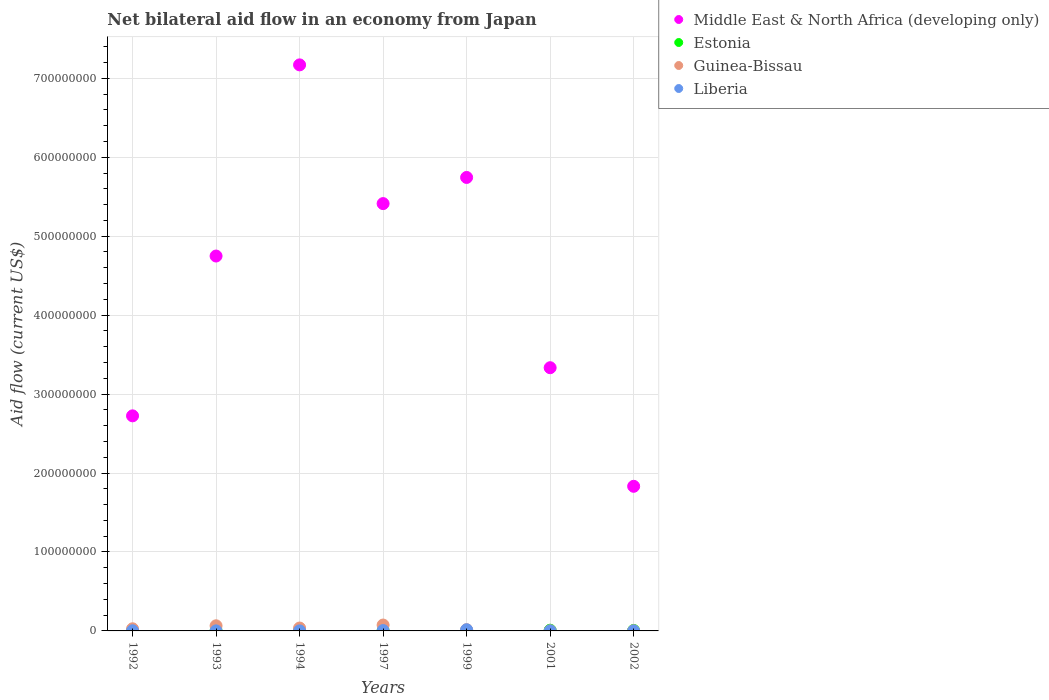Is the number of dotlines equal to the number of legend labels?
Make the answer very short. Yes. What is the net bilateral aid flow in Middle East & North Africa (developing only) in 1993?
Ensure brevity in your answer.  4.75e+08. Across all years, what is the minimum net bilateral aid flow in Estonia?
Keep it short and to the point. 3.00e+04. What is the total net bilateral aid flow in Liberia in the graph?
Provide a short and direct response. 2.28e+06. What is the difference between the net bilateral aid flow in Estonia in 1997 and that in 2001?
Keep it short and to the point. -6.80e+05. What is the difference between the net bilateral aid flow in Guinea-Bissau in 1992 and the net bilateral aid flow in Estonia in 1999?
Keep it short and to the point. 2.40e+06. What is the average net bilateral aid flow in Liberia per year?
Offer a terse response. 3.26e+05. In the year 1997, what is the difference between the net bilateral aid flow in Guinea-Bissau and net bilateral aid flow in Liberia?
Give a very brief answer. 7.01e+06. What is the ratio of the net bilateral aid flow in Estonia in 1997 to that in 1999?
Your answer should be compact. 0.73. What is the difference between the highest and the second highest net bilateral aid flow in Liberia?
Offer a very short reply. 1.02e+06. What is the difference between the highest and the lowest net bilateral aid flow in Middle East & North Africa (developing only)?
Make the answer very short. 5.34e+08. Is the sum of the net bilateral aid flow in Middle East & North Africa (developing only) in 1999 and 2001 greater than the maximum net bilateral aid flow in Liberia across all years?
Provide a short and direct response. Yes. Does the net bilateral aid flow in Estonia monotonically increase over the years?
Your answer should be very brief. No. Is the net bilateral aid flow in Guinea-Bissau strictly greater than the net bilateral aid flow in Estonia over the years?
Offer a very short reply. No. How many years are there in the graph?
Keep it short and to the point. 7. Does the graph contain any zero values?
Keep it short and to the point. No. How many legend labels are there?
Provide a short and direct response. 4. What is the title of the graph?
Ensure brevity in your answer.  Net bilateral aid flow in an economy from Japan. What is the label or title of the X-axis?
Ensure brevity in your answer.  Years. What is the Aid flow (current US$) in Middle East & North Africa (developing only) in 1992?
Keep it short and to the point. 2.72e+08. What is the Aid flow (current US$) of Estonia in 1992?
Ensure brevity in your answer.  3.00e+04. What is the Aid flow (current US$) of Guinea-Bissau in 1992?
Your answer should be very brief. 2.70e+06. What is the Aid flow (current US$) in Liberia in 1992?
Your answer should be compact. 2.00e+05. What is the Aid flow (current US$) in Middle East & North Africa (developing only) in 1993?
Your answer should be very brief. 4.75e+08. What is the Aid flow (current US$) of Estonia in 1993?
Your response must be concise. 1.30e+05. What is the Aid flow (current US$) of Guinea-Bissau in 1993?
Ensure brevity in your answer.  6.51e+06. What is the Aid flow (current US$) in Liberia in 1993?
Give a very brief answer. 6.00e+04. What is the Aid flow (current US$) of Middle East & North Africa (developing only) in 1994?
Provide a succinct answer. 7.17e+08. What is the Aid flow (current US$) in Guinea-Bissau in 1994?
Make the answer very short. 3.66e+06. What is the Aid flow (current US$) in Middle East & North Africa (developing only) in 1997?
Make the answer very short. 5.41e+08. What is the Aid flow (current US$) of Guinea-Bissau in 1997?
Make the answer very short. 7.46e+06. What is the Aid flow (current US$) of Middle East & North Africa (developing only) in 1999?
Offer a very short reply. 5.74e+08. What is the Aid flow (current US$) of Estonia in 1999?
Offer a very short reply. 3.00e+05. What is the Aid flow (current US$) in Guinea-Bissau in 1999?
Ensure brevity in your answer.  1.53e+06. What is the Aid flow (current US$) in Liberia in 1999?
Your response must be concise. 1.47e+06. What is the Aid flow (current US$) in Middle East & North Africa (developing only) in 2001?
Make the answer very short. 3.33e+08. What is the Aid flow (current US$) of Guinea-Bissau in 2001?
Keep it short and to the point. 1.80e+05. What is the Aid flow (current US$) in Middle East & North Africa (developing only) in 2002?
Make the answer very short. 1.83e+08. What is the Aid flow (current US$) in Estonia in 2002?
Offer a very short reply. 6.10e+05. Across all years, what is the maximum Aid flow (current US$) of Middle East & North Africa (developing only)?
Your answer should be very brief. 7.17e+08. Across all years, what is the maximum Aid flow (current US$) of Estonia?
Your response must be concise. 9.00e+05. Across all years, what is the maximum Aid flow (current US$) in Guinea-Bissau?
Ensure brevity in your answer.  7.46e+06. Across all years, what is the maximum Aid flow (current US$) of Liberia?
Make the answer very short. 1.47e+06. Across all years, what is the minimum Aid flow (current US$) of Middle East & North Africa (developing only)?
Keep it short and to the point. 1.83e+08. Across all years, what is the minimum Aid flow (current US$) of Guinea-Bissau?
Ensure brevity in your answer.  1.20e+05. Across all years, what is the minimum Aid flow (current US$) in Liberia?
Give a very brief answer. 2.00e+04. What is the total Aid flow (current US$) in Middle East & North Africa (developing only) in the graph?
Offer a terse response. 3.10e+09. What is the total Aid flow (current US$) of Estonia in the graph?
Your response must be concise. 2.27e+06. What is the total Aid flow (current US$) of Guinea-Bissau in the graph?
Your response must be concise. 2.22e+07. What is the total Aid flow (current US$) in Liberia in the graph?
Make the answer very short. 2.28e+06. What is the difference between the Aid flow (current US$) of Middle East & North Africa (developing only) in 1992 and that in 1993?
Provide a succinct answer. -2.02e+08. What is the difference between the Aid flow (current US$) of Guinea-Bissau in 1992 and that in 1993?
Offer a terse response. -3.81e+06. What is the difference between the Aid flow (current US$) of Liberia in 1992 and that in 1993?
Offer a very short reply. 1.40e+05. What is the difference between the Aid flow (current US$) in Middle East & North Africa (developing only) in 1992 and that in 1994?
Ensure brevity in your answer.  -4.45e+08. What is the difference between the Aid flow (current US$) in Guinea-Bissau in 1992 and that in 1994?
Your answer should be compact. -9.60e+05. What is the difference between the Aid flow (current US$) in Liberia in 1992 and that in 1994?
Your answer should be compact. 1.70e+05. What is the difference between the Aid flow (current US$) of Middle East & North Africa (developing only) in 1992 and that in 1997?
Provide a succinct answer. -2.69e+08. What is the difference between the Aid flow (current US$) of Estonia in 1992 and that in 1997?
Your answer should be compact. -1.90e+05. What is the difference between the Aid flow (current US$) in Guinea-Bissau in 1992 and that in 1997?
Your response must be concise. -4.76e+06. What is the difference between the Aid flow (current US$) in Liberia in 1992 and that in 1997?
Your response must be concise. -2.50e+05. What is the difference between the Aid flow (current US$) of Middle East & North Africa (developing only) in 1992 and that in 1999?
Make the answer very short. -3.02e+08. What is the difference between the Aid flow (current US$) in Guinea-Bissau in 1992 and that in 1999?
Give a very brief answer. 1.17e+06. What is the difference between the Aid flow (current US$) of Liberia in 1992 and that in 1999?
Ensure brevity in your answer.  -1.27e+06. What is the difference between the Aid flow (current US$) of Middle East & North Africa (developing only) in 1992 and that in 2001?
Your answer should be compact. -6.10e+07. What is the difference between the Aid flow (current US$) in Estonia in 1992 and that in 2001?
Provide a succinct answer. -8.70e+05. What is the difference between the Aid flow (current US$) of Guinea-Bissau in 1992 and that in 2001?
Provide a short and direct response. 2.52e+06. What is the difference between the Aid flow (current US$) of Liberia in 1992 and that in 2001?
Make the answer very short. 1.50e+05. What is the difference between the Aid flow (current US$) in Middle East & North Africa (developing only) in 1992 and that in 2002?
Ensure brevity in your answer.  8.92e+07. What is the difference between the Aid flow (current US$) in Estonia in 1992 and that in 2002?
Make the answer very short. -5.80e+05. What is the difference between the Aid flow (current US$) in Guinea-Bissau in 1992 and that in 2002?
Keep it short and to the point. 2.58e+06. What is the difference between the Aid flow (current US$) of Liberia in 1992 and that in 2002?
Your answer should be very brief. 1.80e+05. What is the difference between the Aid flow (current US$) in Middle East & North Africa (developing only) in 1993 and that in 1994?
Provide a succinct answer. -2.42e+08. What is the difference between the Aid flow (current US$) in Estonia in 1993 and that in 1994?
Give a very brief answer. 5.00e+04. What is the difference between the Aid flow (current US$) of Guinea-Bissau in 1993 and that in 1994?
Provide a short and direct response. 2.85e+06. What is the difference between the Aid flow (current US$) of Liberia in 1993 and that in 1994?
Provide a short and direct response. 3.00e+04. What is the difference between the Aid flow (current US$) of Middle East & North Africa (developing only) in 1993 and that in 1997?
Your response must be concise. -6.64e+07. What is the difference between the Aid flow (current US$) of Estonia in 1993 and that in 1997?
Keep it short and to the point. -9.00e+04. What is the difference between the Aid flow (current US$) of Guinea-Bissau in 1993 and that in 1997?
Provide a short and direct response. -9.50e+05. What is the difference between the Aid flow (current US$) in Liberia in 1993 and that in 1997?
Provide a succinct answer. -3.90e+05. What is the difference between the Aid flow (current US$) of Middle East & North Africa (developing only) in 1993 and that in 1999?
Offer a very short reply. -9.96e+07. What is the difference between the Aid flow (current US$) in Estonia in 1993 and that in 1999?
Offer a terse response. -1.70e+05. What is the difference between the Aid flow (current US$) of Guinea-Bissau in 1993 and that in 1999?
Offer a terse response. 4.98e+06. What is the difference between the Aid flow (current US$) in Liberia in 1993 and that in 1999?
Your answer should be compact. -1.41e+06. What is the difference between the Aid flow (current US$) in Middle East & North Africa (developing only) in 1993 and that in 2001?
Your response must be concise. 1.41e+08. What is the difference between the Aid flow (current US$) in Estonia in 1993 and that in 2001?
Provide a short and direct response. -7.70e+05. What is the difference between the Aid flow (current US$) in Guinea-Bissau in 1993 and that in 2001?
Your answer should be compact. 6.33e+06. What is the difference between the Aid flow (current US$) in Middle East & North Africa (developing only) in 1993 and that in 2002?
Offer a terse response. 2.92e+08. What is the difference between the Aid flow (current US$) in Estonia in 1993 and that in 2002?
Your answer should be compact. -4.80e+05. What is the difference between the Aid flow (current US$) of Guinea-Bissau in 1993 and that in 2002?
Keep it short and to the point. 6.39e+06. What is the difference between the Aid flow (current US$) of Middle East & North Africa (developing only) in 1994 and that in 1997?
Your answer should be very brief. 1.76e+08. What is the difference between the Aid flow (current US$) in Guinea-Bissau in 1994 and that in 1997?
Ensure brevity in your answer.  -3.80e+06. What is the difference between the Aid flow (current US$) in Liberia in 1994 and that in 1997?
Keep it short and to the point. -4.20e+05. What is the difference between the Aid flow (current US$) of Middle East & North Africa (developing only) in 1994 and that in 1999?
Keep it short and to the point. 1.43e+08. What is the difference between the Aid flow (current US$) in Guinea-Bissau in 1994 and that in 1999?
Provide a succinct answer. 2.13e+06. What is the difference between the Aid flow (current US$) in Liberia in 1994 and that in 1999?
Your answer should be very brief. -1.44e+06. What is the difference between the Aid flow (current US$) in Middle East & North Africa (developing only) in 1994 and that in 2001?
Make the answer very short. 3.84e+08. What is the difference between the Aid flow (current US$) in Estonia in 1994 and that in 2001?
Your response must be concise. -8.20e+05. What is the difference between the Aid flow (current US$) in Guinea-Bissau in 1994 and that in 2001?
Your answer should be very brief. 3.48e+06. What is the difference between the Aid flow (current US$) of Liberia in 1994 and that in 2001?
Ensure brevity in your answer.  -2.00e+04. What is the difference between the Aid flow (current US$) in Middle East & North Africa (developing only) in 1994 and that in 2002?
Your answer should be very brief. 5.34e+08. What is the difference between the Aid flow (current US$) in Estonia in 1994 and that in 2002?
Ensure brevity in your answer.  -5.30e+05. What is the difference between the Aid flow (current US$) of Guinea-Bissau in 1994 and that in 2002?
Offer a very short reply. 3.54e+06. What is the difference between the Aid flow (current US$) in Liberia in 1994 and that in 2002?
Give a very brief answer. 10000. What is the difference between the Aid flow (current US$) in Middle East & North Africa (developing only) in 1997 and that in 1999?
Offer a terse response. -3.31e+07. What is the difference between the Aid flow (current US$) in Guinea-Bissau in 1997 and that in 1999?
Your answer should be compact. 5.93e+06. What is the difference between the Aid flow (current US$) of Liberia in 1997 and that in 1999?
Offer a very short reply. -1.02e+06. What is the difference between the Aid flow (current US$) of Middle East & North Africa (developing only) in 1997 and that in 2001?
Keep it short and to the point. 2.08e+08. What is the difference between the Aid flow (current US$) in Estonia in 1997 and that in 2001?
Give a very brief answer. -6.80e+05. What is the difference between the Aid flow (current US$) in Guinea-Bissau in 1997 and that in 2001?
Give a very brief answer. 7.28e+06. What is the difference between the Aid flow (current US$) in Middle East & North Africa (developing only) in 1997 and that in 2002?
Your response must be concise. 3.58e+08. What is the difference between the Aid flow (current US$) in Estonia in 1997 and that in 2002?
Offer a very short reply. -3.90e+05. What is the difference between the Aid flow (current US$) in Guinea-Bissau in 1997 and that in 2002?
Ensure brevity in your answer.  7.34e+06. What is the difference between the Aid flow (current US$) of Liberia in 1997 and that in 2002?
Offer a terse response. 4.30e+05. What is the difference between the Aid flow (current US$) in Middle East & North Africa (developing only) in 1999 and that in 2001?
Your answer should be very brief. 2.41e+08. What is the difference between the Aid flow (current US$) of Estonia in 1999 and that in 2001?
Keep it short and to the point. -6.00e+05. What is the difference between the Aid flow (current US$) of Guinea-Bissau in 1999 and that in 2001?
Offer a very short reply. 1.35e+06. What is the difference between the Aid flow (current US$) in Liberia in 1999 and that in 2001?
Your answer should be very brief. 1.42e+06. What is the difference between the Aid flow (current US$) in Middle East & North Africa (developing only) in 1999 and that in 2002?
Your answer should be very brief. 3.91e+08. What is the difference between the Aid flow (current US$) in Estonia in 1999 and that in 2002?
Provide a short and direct response. -3.10e+05. What is the difference between the Aid flow (current US$) of Guinea-Bissau in 1999 and that in 2002?
Provide a short and direct response. 1.41e+06. What is the difference between the Aid flow (current US$) in Liberia in 1999 and that in 2002?
Ensure brevity in your answer.  1.45e+06. What is the difference between the Aid flow (current US$) in Middle East & North Africa (developing only) in 2001 and that in 2002?
Give a very brief answer. 1.50e+08. What is the difference between the Aid flow (current US$) of Estonia in 2001 and that in 2002?
Offer a terse response. 2.90e+05. What is the difference between the Aid flow (current US$) of Liberia in 2001 and that in 2002?
Your answer should be compact. 3.00e+04. What is the difference between the Aid flow (current US$) of Middle East & North Africa (developing only) in 1992 and the Aid flow (current US$) of Estonia in 1993?
Ensure brevity in your answer.  2.72e+08. What is the difference between the Aid flow (current US$) of Middle East & North Africa (developing only) in 1992 and the Aid flow (current US$) of Guinea-Bissau in 1993?
Ensure brevity in your answer.  2.66e+08. What is the difference between the Aid flow (current US$) of Middle East & North Africa (developing only) in 1992 and the Aid flow (current US$) of Liberia in 1993?
Provide a short and direct response. 2.72e+08. What is the difference between the Aid flow (current US$) of Estonia in 1992 and the Aid flow (current US$) of Guinea-Bissau in 1993?
Provide a succinct answer. -6.48e+06. What is the difference between the Aid flow (current US$) of Guinea-Bissau in 1992 and the Aid flow (current US$) of Liberia in 1993?
Offer a terse response. 2.64e+06. What is the difference between the Aid flow (current US$) of Middle East & North Africa (developing only) in 1992 and the Aid flow (current US$) of Estonia in 1994?
Make the answer very short. 2.72e+08. What is the difference between the Aid flow (current US$) in Middle East & North Africa (developing only) in 1992 and the Aid flow (current US$) in Guinea-Bissau in 1994?
Provide a succinct answer. 2.69e+08. What is the difference between the Aid flow (current US$) of Middle East & North Africa (developing only) in 1992 and the Aid flow (current US$) of Liberia in 1994?
Make the answer very short. 2.72e+08. What is the difference between the Aid flow (current US$) in Estonia in 1992 and the Aid flow (current US$) in Guinea-Bissau in 1994?
Give a very brief answer. -3.63e+06. What is the difference between the Aid flow (current US$) in Guinea-Bissau in 1992 and the Aid flow (current US$) in Liberia in 1994?
Offer a very short reply. 2.67e+06. What is the difference between the Aid flow (current US$) of Middle East & North Africa (developing only) in 1992 and the Aid flow (current US$) of Estonia in 1997?
Provide a succinct answer. 2.72e+08. What is the difference between the Aid flow (current US$) in Middle East & North Africa (developing only) in 1992 and the Aid flow (current US$) in Guinea-Bissau in 1997?
Keep it short and to the point. 2.65e+08. What is the difference between the Aid flow (current US$) in Middle East & North Africa (developing only) in 1992 and the Aid flow (current US$) in Liberia in 1997?
Your answer should be compact. 2.72e+08. What is the difference between the Aid flow (current US$) of Estonia in 1992 and the Aid flow (current US$) of Guinea-Bissau in 1997?
Your response must be concise. -7.43e+06. What is the difference between the Aid flow (current US$) of Estonia in 1992 and the Aid flow (current US$) of Liberia in 1997?
Your response must be concise. -4.20e+05. What is the difference between the Aid flow (current US$) in Guinea-Bissau in 1992 and the Aid flow (current US$) in Liberia in 1997?
Your answer should be very brief. 2.25e+06. What is the difference between the Aid flow (current US$) of Middle East & North Africa (developing only) in 1992 and the Aid flow (current US$) of Estonia in 1999?
Your answer should be compact. 2.72e+08. What is the difference between the Aid flow (current US$) of Middle East & North Africa (developing only) in 1992 and the Aid flow (current US$) of Guinea-Bissau in 1999?
Keep it short and to the point. 2.71e+08. What is the difference between the Aid flow (current US$) in Middle East & North Africa (developing only) in 1992 and the Aid flow (current US$) in Liberia in 1999?
Offer a very short reply. 2.71e+08. What is the difference between the Aid flow (current US$) of Estonia in 1992 and the Aid flow (current US$) of Guinea-Bissau in 1999?
Keep it short and to the point. -1.50e+06. What is the difference between the Aid flow (current US$) of Estonia in 1992 and the Aid flow (current US$) of Liberia in 1999?
Your response must be concise. -1.44e+06. What is the difference between the Aid flow (current US$) of Guinea-Bissau in 1992 and the Aid flow (current US$) of Liberia in 1999?
Offer a very short reply. 1.23e+06. What is the difference between the Aid flow (current US$) of Middle East & North Africa (developing only) in 1992 and the Aid flow (current US$) of Estonia in 2001?
Make the answer very short. 2.72e+08. What is the difference between the Aid flow (current US$) in Middle East & North Africa (developing only) in 1992 and the Aid flow (current US$) in Guinea-Bissau in 2001?
Offer a very short reply. 2.72e+08. What is the difference between the Aid flow (current US$) in Middle East & North Africa (developing only) in 1992 and the Aid flow (current US$) in Liberia in 2001?
Your response must be concise. 2.72e+08. What is the difference between the Aid flow (current US$) of Estonia in 1992 and the Aid flow (current US$) of Guinea-Bissau in 2001?
Your answer should be compact. -1.50e+05. What is the difference between the Aid flow (current US$) in Guinea-Bissau in 1992 and the Aid flow (current US$) in Liberia in 2001?
Your answer should be compact. 2.65e+06. What is the difference between the Aid flow (current US$) in Middle East & North Africa (developing only) in 1992 and the Aid flow (current US$) in Estonia in 2002?
Provide a succinct answer. 2.72e+08. What is the difference between the Aid flow (current US$) of Middle East & North Africa (developing only) in 1992 and the Aid flow (current US$) of Guinea-Bissau in 2002?
Make the answer very short. 2.72e+08. What is the difference between the Aid flow (current US$) of Middle East & North Africa (developing only) in 1992 and the Aid flow (current US$) of Liberia in 2002?
Your answer should be very brief. 2.72e+08. What is the difference between the Aid flow (current US$) in Estonia in 1992 and the Aid flow (current US$) in Guinea-Bissau in 2002?
Your response must be concise. -9.00e+04. What is the difference between the Aid flow (current US$) in Guinea-Bissau in 1992 and the Aid flow (current US$) in Liberia in 2002?
Keep it short and to the point. 2.68e+06. What is the difference between the Aid flow (current US$) of Middle East & North Africa (developing only) in 1993 and the Aid flow (current US$) of Estonia in 1994?
Offer a terse response. 4.75e+08. What is the difference between the Aid flow (current US$) of Middle East & North Africa (developing only) in 1993 and the Aid flow (current US$) of Guinea-Bissau in 1994?
Your answer should be compact. 4.71e+08. What is the difference between the Aid flow (current US$) of Middle East & North Africa (developing only) in 1993 and the Aid flow (current US$) of Liberia in 1994?
Provide a succinct answer. 4.75e+08. What is the difference between the Aid flow (current US$) in Estonia in 1993 and the Aid flow (current US$) in Guinea-Bissau in 1994?
Make the answer very short. -3.53e+06. What is the difference between the Aid flow (current US$) of Estonia in 1993 and the Aid flow (current US$) of Liberia in 1994?
Make the answer very short. 1.00e+05. What is the difference between the Aid flow (current US$) of Guinea-Bissau in 1993 and the Aid flow (current US$) of Liberia in 1994?
Provide a succinct answer. 6.48e+06. What is the difference between the Aid flow (current US$) of Middle East & North Africa (developing only) in 1993 and the Aid flow (current US$) of Estonia in 1997?
Ensure brevity in your answer.  4.75e+08. What is the difference between the Aid flow (current US$) of Middle East & North Africa (developing only) in 1993 and the Aid flow (current US$) of Guinea-Bissau in 1997?
Make the answer very short. 4.67e+08. What is the difference between the Aid flow (current US$) in Middle East & North Africa (developing only) in 1993 and the Aid flow (current US$) in Liberia in 1997?
Give a very brief answer. 4.74e+08. What is the difference between the Aid flow (current US$) in Estonia in 1993 and the Aid flow (current US$) in Guinea-Bissau in 1997?
Your response must be concise. -7.33e+06. What is the difference between the Aid flow (current US$) of Estonia in 1993 and the Aid flow (current US$) of Liberia in 1997?
Your response must be concise. -3.20e+05. What is the difference between the Aid flow (current US$) of Guinea-Bissau in 1993 and the Aid flow (current US$) of Liberia in 1997?
Your response must be concise. 6.06e+06. What is the difference between the Aid flow (current US$) in Middle East & North Africa (developing only) in 1993 and the Aid flow (current US$) in Estonia in 1999?
Your answer should be compact. 4.75e+08. What is the difference between the Aid flow (current US$) in Middle East & North Africa (developing only) in 1993 and the Aid flow (current US$) in Guinea-Bissau in 1999?
Provide a short and direct response. 4.73e+08. What is the difference between the Aid flow (current US$) in Middle East & North Africa (developing only) in 1993 and the Aid flow (current US$) in Liberia in 1999?
Provide a succinct answer. 4.73e+08. What is the difference between the Aid flow (current US$) of Estonia in 1993 and the Aid flow (current US$) of Guinea-Bissau in 1999?
Provide a succinct answer. -1.40e+06. What is the difference between the Aid flow (current US$) of Estonia in 1993 and the Aid flow (current US$) of Liberia in 1999?
Your response must be concise. -1.34e+06. What is the difference between the Aid flow (current US$) of Guinea-Bissau in 1993 and the Aid flow (current US$) of Liberia in 1999?
Offer a terse response. 5.04e+06. What is the difference between the Aid flow (current US$) in Middle East & North Africa (developing only) in 1993 and the Aid flow (current US$) in Estonia in 2001?
Provide a short and direct response. 4.74e+08. What is the difference between the Aid flow (current US$) of Middle East & North Africa (developing only) in 1993 and the Aid flow (current US$) of Guinea-Bissau in 2001?
Your answer should be compact. 4.75e+08. What is the difference between the Aid flow (current US$) of Middle East & North Africa (developing only) in 1993 and the Aid flow (current US$) of Liberia in 2001?
Give a very brief answer. 4.75e+08. What is the difference between the Aid flow (current US$) of Estonia in 1993 and the Aid flow (current US$) of Guinea-Bissau in 2001?
Provide a short and direct response. -5.00e+04. What is the difference between the Aid flow (current US$) in Guinea-Bissau in 1993 and the Aid flow (current US$) in Liberia in 2001?
Your response must be concise. 6.46e+06. What is the difference between the Aid flow (current US$) of Middle East & North Africa (developing only) in 1993 and the Aid flow (current US$) of Estonia in 2002?
Keep it short and to the point. 4.74e+08. What is the difference between the Aid flow (current US$) of Middle East & North Africa (developing only) in 1993 and the Aid flow (current US$) of Guinea-Bissau in 2002?
Make the answer very short. 4.75e+08. What is the difference between the Aid flow (current US$) of Middle East & North Africa (developing only) in 1993 and the Aid flow (current US$) of Liberia in 2002?
Your answer should be very brief. 4.75e+08. What is the difference between the Aid flow (current US$) of Estonia in 1993 and the Aid flow (current US$) of Guinea-Bissau in 2002?
Offer a terse response. 10000. What is the difference between the Aid flow (current US$) of Estonia in 1993 and the Aid flow (current US$) of Liberia in 2002?
Make the answer very short. 1.10e+05. What is the difference between the Aid flow (current US$) in Guinea-Bissau in 1993 and the Aid flow (current US$) in Liberia in 2002?
Ensure brevity in your answer.  6.49e+06. What is the difference between the Aid flow (current US$) of Middle East & North Africa (developing only) in 1994 and the Aid flow (current US$) of Estonia in 1997?
Provide a short and direct response. 7.17e+08. What is the difference between the Aid flow (current US$) of Middle East & North Africa (developing only) in 1994 and the Aid flow (current US$) of Guinea-Bissau in 1997?
Your answer should be compact. 7.10e+08. What is the difference between the Aid flow (current US$) of Middle East & North Africa (developing only) in 1994 and the Aid flow (current US$) of Liberia in 1997?
Offer a terse response. 7.17e+08. What is the difference between the Aid flow (current US$) in Estonia in 1994 and the Aid flow (current US$) in Guinea-Bissau in 1997?
Make the answer very short. -7.38e+06. What is the difference between the Aid flow (current US$) of Estonia in 1994 and the Aid flow (current US$) of Liberia in 1997?
Give a very brief answer. -3.70e+05. What is the difference between the Aid flow (current US$) in Guinea-Bissau in 1994 and the Aid flow (current US$) in Liberia in 1997?
Keep it short and to the point. 3.21e+06. What is the difference between the Aid flow (current US$) in Middle East & North Africa (developing only) in 1994 and the Aid flow (current US$) in Estonia in 1999?
Your answer should be very brief. 7.17e+08. What is the difference between the Aid flow (current US$) of Middle East & North Africa (developing only) in 1994 and the Aid flow (current US$) of Guinea-Bissau in 1999?
Ensure brevity in your answer.  7.15e+08. What is the difference between the Aid flow (current US$) of Middle East & North Africa (developing only) in 1994 and the Aid flow (current US$) of Liberia in 1999?
Make the answer very short. 7.16e+08. What is the difference between the Aid flow (current US$) in Estonia in 1994 and the Aid flow (current US$) in Guinea-Bissau in 1999?
Give a very brief answer. -1.45e+06. What is the difference between the Aid flow (current US$) in Estonia in 1994 and the Aid flow (current US$) in Liberia in 1999?
Provide a succinct answer. -1.39e+06. What is the difference between the Aid flow (current US$) in Guinea-Bissau in 1994 and the Aid flow (current US$) in Liberia in 1999?
Provide a short and direct response. 2.19e+06. What is the difference between the Aid flow (current US$) of Middle East & North Africa (developing only) in 1994 and the Aid flow (current US$) of Estonia in 2001?
Ensure brevity in your answer.  7.16e+08. What is the difference between the Aid flow (current US$) in Middle East & North Africa (developing only) in 1994 and the Aid flow (current US$) in Guinea-Bissau in 2001?
Provide a short and direct response. 7.17e+08. What is the difference between the Aid flow (current US$) in Middle East & North Africa (developing only) in 1994 and the Aid flow (current US$) in Liberia in 2001?
Offer a terse response. 7.17e+08. What is the difference between the Aid flow (current US$) in Estonia in 1994 and the Aid flow (current US$) in Guinea-Bissau in 2001?
Keep it short and to the point. -1.00e+05. What is the difference between the Aid flow (current US$) of Estonia in 1994 and the Aid flow (current US$) of Liberia in 2001?
Offer a very short reply. 3.00e+04. What is the difference between the Aid flow (current US$) of Guinea-Bissau in 1994 and the Aid flow (current US$) of Liberia in 2001?
Provide a short and direct response. 3.61e+06. What is the difference between the Aid flow (current US$) in Middle East & North Africa (developing only) in 1994 and the Aid flow (current US$) in Estonia in 2002?
Your response must be concise. 7.16e+08. What is the difference between the Aid flow (current US$) in Middle East & North Africa (developing only) in 1994 and the Aid flow (current US$) in Guinea-Bissau in 2002?
Give a very brief answer. 7.17e+08. What is the difference between the Aid flow (current US$) of Middle East & North Africa (developing only) in 1994 and the Aid flow (current US$) of Liberia in 2002?
Keep it short and to the point. 7.17e+08. What is the difference between the Aid flow (current US$) in Guinea-Bissau in 1994 and the Aid flow (current US$) in Liberia in 2002?
Offer a terse response. 3.64e+06. What is the difference between the Aid flow (current US$) in Middle East & North Africa (developing only) in 1997 and the Aid flow (current US$) in Estonia in 1999?
Keep it short and to the point. 5.41e+08. What is the difference between the Aid flow (current US$) of Middle East & North Africa (developing only) in 1997 and the Aid flow (current US$) of Guinea-Bissau in 1999?
Your answer should be very brief. 5.40e+08. What is the difference between the Aid flow (current US$) of Middle East & North Africa (developing only) in 1997 and the Aid flow (current US$) of Liberia in 1999?
Make the answer very short. 5.40e+08. What is the difference between the Aid flow (current US$) of Estonia in 1997 and the Aid flow (current US$) of Guinea-Bissau in 1999?
Give a very brief answer. -1.31e+06. What is the difference between the Aid flow (current US$) of Estonia in 1997 and the Aid flow (current US$) of Liberia in 1999?
Give a very brief answer. -1.25e+06. What is the difference between the Aid flow (current US$) of Guinea-Bissau in 1997 and the Aid flow (current US$) of Liberia in 1999?
Offer a terse response. 5.99e+06. What is the difference between the Aid flow (current US$) of Middle East & North Africa (developing only) in 1997 and the Aid flow (current US$) of Estonia in 2001?
Your response must be concise. 5.40e+08. What is the difference between the Aid flow (current US$) in Middle East & North Africa (developing only) in 1997 and the Aid flow (current US$) in Guinea-Bissau in 2001?
Offer a terse response. 5.41e+08. What is the difference between the Aid flow (current US$) of Middle East & North Africa (developing only) in 1997 and the Aid flow (current US$) of Liberia in 2001?
Your answer should be very brief. 5.41e+08. What is the difference between the Aid flow (current US$) of Guinea-Bissau in 1997 and the Aid flow (current US$) of Liberia in 2001?
Offer a terse response. 7.41e+06. What is the difference between the Aid flow (current US$) in Middle East & North Africa (developing only) in 1997 and the Aid flow (current US$) in Estonia in 2002?
Provide a short and direct response. 5.41e+08. What is the difference between the Aid flow (current US$) in Middle East & North Africa (developing only) in 1997 and the Aid flow (current US$) in Guinea-Bissau in 2002?
Offer a terse response. 5.41e+08. What is the difference between the Aid flow (current US$) of Middle East & North Africa (developing only) in 1997 and the Aid flow (current US$) of Liberia in 2002?
Keep it short and to the point. 5.41e+08. What is the difference between the Aid flow (current US$) in Guinea-Bissau in 1997 and the Aid flow (current US$) in Liberia in 2002?
Your answer should be compact. 7.44e+06. What is the difference between the Aid flow (current US$) in Middle East & North Africa (developing only) in 1999 and the Aid flow (current US$) in Estonia in 2001?
Your answer should be compact. 5.74e+08. What is the difference between the Aid flow (current US$) in Middle East & North Africa (developing only) in 1999 and the Aid flow (current US$) in Guinea-Bissau in 2001?
Make the answer very short. 5.74e+08. What is the difference between the Aid flow (current US$) of Middle East & North Africa (developing only) in 1999 and the Aid flow (current US$) of Liberia in 2001?
Make the answer very short. 5.74e+08. What is the difference between the Aid flow (current US$) of Guinea-Bissau in 1999 and the Aid flow (current US$) of Liberia in 2001?
Provide a short and direct response. 1.48e+06. What is the difference between the Aid flow (current US$) of Middle East & North Africa (developing only) in 1999 and the Aid flow (current US$) of Estonia in 2002?
Your response must be concise. 5.74e+08. What is the difference between the Aid flow (current US$) of Middle East & North Africa (developing only) in 1999 and the Aid flow (current US$) of Guinea-Bissau in 2002?
Provide a succinct answer. 5.74e+08. What is the difference between the Aid flow (current US$) in Middle East & North Africa (developing only) in 1999 and the Aid flow (current US$) in Liberia in 2002?
Your answer should be very brief. 5.74e+08. What is the difference between the Aid flow (current US$) of Estonia in 1999 and the Aid flow (current US$) of Liberia in 2002?
Offer a very short reply. 2.80e+05. What is the difference between the Aid flow (current US$) in Guinea-Bissau in 1999 and the Aid flow (current US$) in Liberia in 2002?
Keep it short and to the point. 1.51e+06. What is the difference between the Aid flow (current US$) in Middle East & North Africa (developing only) in 2001 and the Aid flow (current US$) in Estonia in 2002?
Your answer should be compact. 3.33e+08. What is the difference between the Aid flow (current US$) of Middle East & North Africa (developing only) in 2001 and the Aid flow (current US$) of Guinea-Bissau in 2002?
Provide a succinct answer. 3.33e+08. What is the difference between the Aid flow (current US$) in Middle East & North Africa (developing only) in 2001 and the Aid flow (current US$) in Liberia in 2002?
Offer a very short reply. 3.33e+08. What is the difference between the Aid flow (current US$) of Estonia in 2001 and the Aid flow (current US$) of Guinea-Bissau in 2002?
Provide a succinct answer. 7.80e+05. What is the difference between the Aid flow (current US$) of Estonia in 2001 and the Aid flow (current US$) of Liberia in 2002?
Give a very brief answer. 8.80e+05. What is the difference between the Aid flow (current US$) of Guinea-Bissau in 2001 and the Aid flow (current US$) of Liberia in 2002?
Provide a succinct answer. 1.60e+05. What is the average Aid flow (current US$) in Middle East & North Africa (developing only) per year?
Your answer should be compact. 4.42e+08. What is the average Aid flow (current US$) of Estonia per year?
Provide a succinct answer. 3.24e+05. What is the average Aid flow (current US$) of Guinea-Bissau per year?
Provide a short and direct response. 3.17e+06. What is the average Aid flow (current US$) in Liberia per year?
Provide a short and direct response. 3.26e+05. In the year 1992, what is the difference between the Aid flow (current US$) in Middle East & North Africa (developing only) and Aid flow (current US$) in Estonia?
Give a very brief answer. 2.72e+08. In the year 1992, what is the difference between the Aid flow (current US$) in Middle East & North Africa (developing only) and Aid flow (current US$) in Guinea-Bissau?
Give a very brief answer. 2.70e+08. In the year 1992, what is the difference between the Aid flow (current US$) of Middle East & North Africa (developing only) and Aid flow (current US$) of Liberia?
Your answer should be compact. 2.72e+08. In the year 1992, what is the difference between the Aid flow (current US$) in Estonia and Aid flow (current US$) in Guinea-Bissau?
Give a very brief answer. -2.67e+06. In the year 1992, what is the difference between the Aid flow (current US$) in Estonia and Aid flow (current US$) in Liberia?
Provide a short and direct response. -1.70e+05. In the year 1992, what is the difference between the Aid flow (current US$) of Guinea-Bissau and Aid flow (current US$) of Liberia?
Provide a short and direct response. 2.50e+06. In the year 1993, what is the difference between the Aid flow (current US$) in Middle East & North Africa (developing only) and Aid flow (current US$) in Estonia?
Your response must be concise. 4.75e+08. In the year 1993, what is the difference between the Aid flow (current US$) of Middle East & North Africa (developing only) and Aid flow (current US$) of Guinea-Bissau?
Your answer should be compact. 4.68e+08. In the year 1993, what is the difference between the Aid flow (current US$) of Middle East & North Africa (developing only) and Aid flow (current US$) of Liberia?
Make the answer very short. 4.75e+08. In the year 1993, what is the difference between the Aid flow (current US$) of Estonia and Aid flow (current US$) of Guinea-Bissau?
Make the answer very short. -6.38e+06. In the year 1993, what is the difference between the Aid flow (current US$) in Guinea-Bissau and Aid flow (current US$) in Liberia?
Make the answer very short. 6.45e+06. In the year 1994, what is the difference between the Aid flow (current US$) of Middle East & North Africa (developing only) and Aid flow (current US$) of Estonia?
Give a very brief answer. 7.17e+08. In the year 1994, what is the difference between the Aid flow (current US$) of Middle East & North Africa (developing only) and Aid flow (current US$) of Guinea-Bissau?
Keep it short and to the point. 7.13e+08. In the year 1994, what is the difference between the Aid flow (current US$) in Middle East & North Africa (developing only) and Aid flow (current US$) in Liberia?
Offer a very short reply. 7.17e+08. In the year 1994, what is the difference between the Aid flow (current US$) in Estonia and Aid flow (current US$) in Guinea-Bissau?
Keep it short and to the point. -3.58e+06. In the year 1994, what is the difference between the Aid flow (current US$) of Estonia and Aid flow (current US$) of Liberia?
Offer a terse response. 5.00e+04. In the year 1994, what is the difference between the Aid flow (current US$) in Guinea-Bissau and Aid flow (current US$) in Liberia?
Your answer should be compact. 3.63e+06. In the year 1997, what is the difference between the Aid flow (current US$) in Middle East & North Africa (developing only) and Aid flow (current US$) in Estonia?
Provide a short and direct response. 5.41e+08. In the year 1997, what is the difference between the Aid flow (current US$) of Middle East & North Africa (developing only) and Aid flow (current US$) of Guinea-Bissau?
Make the answer very short. 5.34e+08. In the year 1997, what is the difference between the Aid flow (current US$) in Middle East & North Africa (developing only) and Aid flow (current US$) in Liberia?
Offer a terse response. 5.41e+08. In the year 1997, what is the difference between the Aid flow (current US$) in Estonia and Aid flow (current US$) in Guinea-Bissau?
Ensure brevity in your answer.  -7.24e+06. In the year 1997, what is the difference between the Aid flow (current US$) in Guinea-Bissau and Aid flow (current US$) in Liberia?
Keep it short and to the point. 7.01e+06. In the year 1999, what is the difference between the Aid flow (current US$) of Middle East & North Africa (developing only) and Aid flow (current US$) of Estonia?
Offer a very short reply. 5.74e+08. In the year 1999, what is the difference between the Aid flow (current US$) in Middle East & North Africa (developing only) and Aid flow (current US$) in Guinea-Bissau?
Offer a terse response. 5.73e+08. In the year 1999, what is the difference between the Aid flow (current US$) of Middle East & North Africa (developing only) and Aid flow (current US$) of Liberia?
Provide a succinct answer. 5.73e+08. In the year 1999, what is the difference between the Aid flow (current US$) of Estonia and Aid flow (current US$) of Guinea-Bissau?
Keep it short and to the point. -1.23e+06. In the year 1999, what is the difference between the Aid flow (current US$) of Estonia and Aid flow (current US$) of Liberia?
Provide a succinct answer. -1.17e+06. In the year 2001, what is the difference between the Aid flow (current US$) in Middle East & North Africa (developing only) and Aid flow (current US$) in Estonia?
Offer a terse response. 3.33e+08. In the year 2001, what is the difference between the Aid flow (current US$) of Middle East & North Africa (developing only) and Aid flow (current US$) of Guinea-Bissau?
Your answer should be very brief. 3.33e+08. In the year 2001, what is the difference between the Aid flow (current US$) in Middle East & North Africa (developing only) and Aid flow (current US$) in Liberia?
Keep it short and to the point. 3.33e+08. In the year 2001, what is the difference between the Aid flow (current US$) of Estonia and Aid flow (current US$) of Guinea-Bissau?
Your response must be concise. 7.20e+05. In the year 2001, what is the difference between the Aid flow (current US$) of Estonia and Aid flow (current US$) of Liberia?
Offer a terse response. 8.50e+05. In the year 2002, what is the difference between the Aid flow (current US$) in Middle East & North Africa (developing only) and Aid flow (current US$) in Estonia?
Ensure brevity in your answer.  1.83e+08. In the year 2002, what is the difference between the Aid flow (current US$) in Middle East & North Africa (developing only) and Aid flow (current US$) in Guinea-Bissau?
Keep it short and to the point. 1.83e+08. In the year 2002, what is the difference between the Aid flow (current US$) in Middle East & North Africa (developing only) and Aid flow (current US$) in Liberia?
Your response must be concise. 1.83e+08. In the year 2002, what is the difference between the Aid flow (current US$) of Estonia and Aid flow (current US$) of Liberia?
Your answer should be very brief. 5.90e+05. In the year 2002, what is the difference between the Aid flow (current US$) in Guinea-Bissau and Aid flow (current US$) in Liberia?
Your answer should be very brief. 1.00e+05. What is the ratio of the Aid flow (current US$) of Middle East & North Africa (developing only) in 1992 to that in 1993?
Your response must be concise. 0.57. What is the ratio of the Aid flow (current US$) of Estonia in 1992 to that in 1993?
Your answer should be very brief. 0.23. What is the ratio of the Aid flow (current US$) of Guinea-Bissau in 1992 to that in 1993?
Offer a terse response. 0.41. What is the ratio of the Aid flow (current US$) in Liberia in 1992 to that in 1993?
Offer a very short reply. 3.33. What is the ratio of the Aid flow (current US$) in Middle East & North Africa (developing only) in 1992 to that in 1994?
Provide a short and direct response. 0.38. What is the ratio of the Aid flow (current US$) in Guinea-Bissau in 1992 to that in 1994?
Keep it short and to the point. 0.74. What is the ratio of the Aid flow (current US$) in Middle East & North Africa (developing only) in 1992 to that in 1997?
Provide a short and direct response. 0.5. What is the ratio of the Aid flow (current US$) in Estonia in 1992 to that in 1997?
Your response must be concise. 0.14. What is the ratio of the Aid flow (current US$) of Guinea-Bissau in 1992 to that in 1997?
Your response must be concise. 0.36. What is the ratio of the Aid flow (current US$) of Liberia in 1992 to that in 1997?
Provide a short and direct response. 0.44. What is the ratio of the Aid flow (current US$) in Middle East & North Africa (developing only) in 1992 to that in 1999?
Your answer should be very brief. 0.47. What is the ratio of the Aid flow (current US$) in Guinea-Bissau in 1992 to that in 1999?
Your response must be concise. 1.76. What is the ratio of the Aid flow (current US$) in Liberia in 1992 to that in 1999?
Provide a succinct answer. 0.14. What is the ratio of the Aid flow (current US$) of Middle East & North Africa (developing only) in 1992 to that in 2001?
Make the answer very short. 0.82. What is the ratio of the Aid flow (current US$) in Guinea-Bissau in 1992 to that in 2001?
Your response must be concise. 15. What is the ratio of the Aid flow (current US$) of Liberia in 1992 to that in 2001?
Keep it short and to the point. 4. What is the ratio of the Aid flow (current US$) in Middle East & North Africa (developing only) in 1992 to that in 2002?
Offer a terse response. 1.49. What is the ratio of the Aid flow (current US$) in Estonia in 1992 to that in 2002?
Give a very brief answer. 0.05. What is the ratio of the Aid flow (current US$) in Liberia in 1992 to that in 2002?
Make the answer very short. 10. What is the ratio of the Aid flow (current US$) in Middle East & North Africa (developing only) in 1993 to that in 1994?
Ensure brevity in your answer.  0.66. What is the ratio of the Aid flow (current US$) in Estonia in 1993 to that in 1994?
Provide a succinct answer. 1.62. What is the ratio of the Aid flow (current US$) in Guinea-Bissau in 1993 to that in 1994?
Offer a terse response. 1.78. What is the ratio of the Aid flow (current US$) in Middle East & North Africa (developing only) in 1993 to that in 1997?
Offer a terse response. 0.88. What is the ratio of the Aid flow (current US$) of Estonia in 1993 to that in 1997?
Provide a short and direct response. 0.59. What is the ratio of the Aid flow (current US$) in Guinea-Bissau in 1993 to that in 1997?
Your answer should be very brief. 0.87. What is the ratio of the Aid flow (current US$) in Liberia in 1993 to that in 1997?
Your answer should be compact. 0.13. What is the ratio of the Aid flow (current US$) of Middle East & North Africa (developing only) in 1993 to that in 1999?
Your response must be concise. 0.83. What is the ratio of the Aid flow (current US$) of Estonia in 1993 to that in 1999?
Provide a short and direct response. 0.43. What is the ratio of the Aid flow (current US$) in Guinea-Bissau in 1993 to that in 1999?
Make the answer very short. 4.25. What is the ratio of the Aid flow (current US$) of Liberia in 1993 to that in 1999?
Your response must be concise. 0.04. What is the ratio of the Aid flow (current US$) in Middle East & North Africa (developing only) in 1993 to that in 2001?
Keep it short and to the point. 1.42. What is the ratio of the Aid flow (current US$) in Estonia in 1993 to that in 2001?
Keep it short and to the point. 0.14. What is the ratio of the Aid flow (current US$) in Guinea-Bissau in 1993 to that in 2001?
Offer a terse response. 36.17. What is the ratio of the Aid flow (current US$) in Middle East & North Africa (developing only) in 1993 to that in 2002?
Offer a terse response. 2.59. What is the ratio of the Aid flow (current US$) in Estonia in 1993 to that in 2002?
Keep it short and to the point. 0.21. What is the ratio of the Aid flow (current US$) in Guinea-Bissau in 1993 to that in 2002?
Your answer should be very brief. 54.25. What is the ratio of the Aid flow (current US$) in Middle East & North Africa (developing only) in 1994 to that in 1997?
Give a very brief answer. 1.32. What is the ratio of the Aid flow (current US$) in Estonia in 1994 to that in 1997?
Make the answer very short. 0.36. What is the ratio of the Aid flow (current US$) in Guinea-Bissau in 1994 to that in 1997?
Ensure brevity in your answer.  0.49. What is the ratio of the Aid flow (current US$) of Liberia in 1994 to that in 1997?
Ensure brevity in your answer.  0.07. What is the ratio of the Aid flow (current US$) in Middle East & North Africa (developing only) in 1994 to that in 1999?
Offer a terse response. 1.25. What is the ratio of the Aid flow (current US$) in Estonia in 1994 to that in 1999?
Make the answer very short. 0.27. What is the ratio of the Aid flow (current US$) in Guinea-Bissau in 1994 to that in 1999?
Give a very brief answer. 2.39. What is the ratio of the Aid flow (current US$) in Liberia in 1994 to that in 1999?
Your response must be concise. 0.02. What is the ratio of the Aid flow (current US$) of Middle East & North Africa (developing only) in 1994 to that in 2001?
Keep it short and to the point. 2.15. What is the ratio of the Aid flow (current US$) in Estonia in 1994 to that in 2001?
Provide a succinct answer. 0.09. What is the ratio of the Aid flow (current US$) of Guinea-Bissau in 1994 to that in 2001?
Provide a short and direct response. 20.33. What is the ratio of the Aid flow (current US$) in Liberia in 1994 to that in 2001?
Provide a succinct answer. 0.6. What is the ratio of the Aid flow (current US$) of Middle East & North Africa (developing only) in 1994 to that in 2002?
Give a very brief answer. 3.91. What is the ratio of the Aid flow (current US$) of Estonia in 1994 to that in 2002?
Offer a terse response. 0.13. What is the ratio of the Aid flow (current US$) in Guinea-Bissau in 1994 to that in 2002?
Give a very brief answer. 30.5. What is the ratio of the Aid flow (current US$) in Middle East & North Africa (developing only) in 1997 to that in 1999?
Provide a succinct answer. 0.94. What is the ratio of the Aid flow (current US$) of Estonia in 1997 to that in 1999?
Provide a short and direct response. 0.73. What is the ratio of the Aid flow (current US$) of Guinea-Bissau in 1997 to that in 1999?
Ensure brevity in your answer.  4.88. What is the ratio of the Aid flow (current US$) in Liberia in 1997 to that in 1999?
Keep it short and to the point. 0.31. What is the ratio of the Aid flow (current US$) of Middle East & North Africa (developing only) in 1997 to that in 2001?
Your answer should be compact. 1.62. What is the ratio of the Aid flow (current US$) in Estonia in 1997 to that in 2001?
Your response must be concise. 0.24. What is the ratio of the Aid flow (current US$) in Guinea-Bissau in 1997 to that in 2001?
Provide a succinct answer. 41.44. What is the ratio of the Aid flow (current US$) in Liberia in 1997 to that in 2001?
Make the answer very short. 9. What is the ratio of the Aid flow (current US$) in Middle East & North Africa (developing only) in 1997 to that in 2002?
Offer a very short reply. 2.95. What is the ratio of the Aid flow (current US$) of Estonia in 1997 to that in 2002?
Make the answer very short. 0.36. What is the ratio of the Aid flow (current US$) in Guinea-Bissau in 1997 to that in 2002?
Your response must be concise. 62.17. What is the ratio of the Aid flow (current US$) of Liberia in 1997 to that in 2002?
Make the answer very short. 22.5. What is the ratio of the Aid flow (current US$) of Middle East & North Africa (developing only) in 1999 to that in 2001?
Ensure brevity in your answer.  1.72. What is the ratio of the Aid flow (current US$) of Estonia in 1999 to that in 2001?
Provide a succinct answer. 0.33. What is the ratio of the Aid flow (current US$) of Liberia in 1999 to that in 2001?
Keep it short and to the point. 29.4. What is the ratio of the Aid flow (current US$) of Middle East & North Africa (developing only) in 1999 to that in 2002?
Offer a very short reply. 3.14. What is the ratio of the Aid flow (current US$) in Estonia in 1999 to that in 2002?
Provide a succinct answer. 0.49. What is the ratio of the Aid flow (current US$) of Guinea-Bissau in 1999 to that in 2002?
Your answer should be compact. 12.75. What is the ratio of the Aid flow (current US$) in Liberia in 1999 to that in 2002?
Your answer should be compact. 73.5. What is the ratio of the Aid flow (current US$) in Middle East & North Africa (developing only) in 2001 to that in 2002?
Your answer should be very brief. 1.82. What is the ratio of the Aid flow (current US$) of Estonia in 2001 to that in 2002?
Your response must be concise. 1.48. What is the difference between the highest and the second highest Aid flow (current US$) of Middle East & North Africa (developing only)?
Ensure brevity in your answer.  1.43e+08. What is the difference between the highest and the second highest Aid flow (current US$) in Estonia?
Offer a terse response. 2.90e+05. What is the difference between the highest and the second highest Aid flow (current US$) in Guinea-Bissau?
Make the answer very short. 9.50e+05. What is the difference between the highest and the second highest Aid flow (current US$) in Liberia?
Offer a very short reply. 1.02e+06. What is the difference between the highest and the lowest Aid flow (current US$) in Middle East & North Africa (developing only)?
Make the answer very short. 5.34e+08. What is the difference between the highest and the lowest Aid flow (current US$) of Estonia?
Offer a very short reply. 8.70e+05. What is the difference between the highest and the lowest Aid flow (current US$) in Guinea-Bissau?
Ensure brevity in your answer.  7.34e+06. What is the difference between the highest and the lowest Aid flow (current US$) in Liberia?
Give a very brief answer. 1.45e+06. 